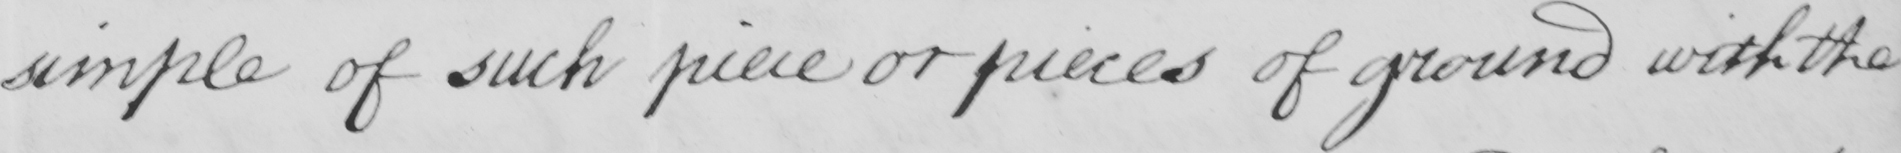Transcribe the text shown in this historical manuscript line. simple of such piece or pieces of ground with the 